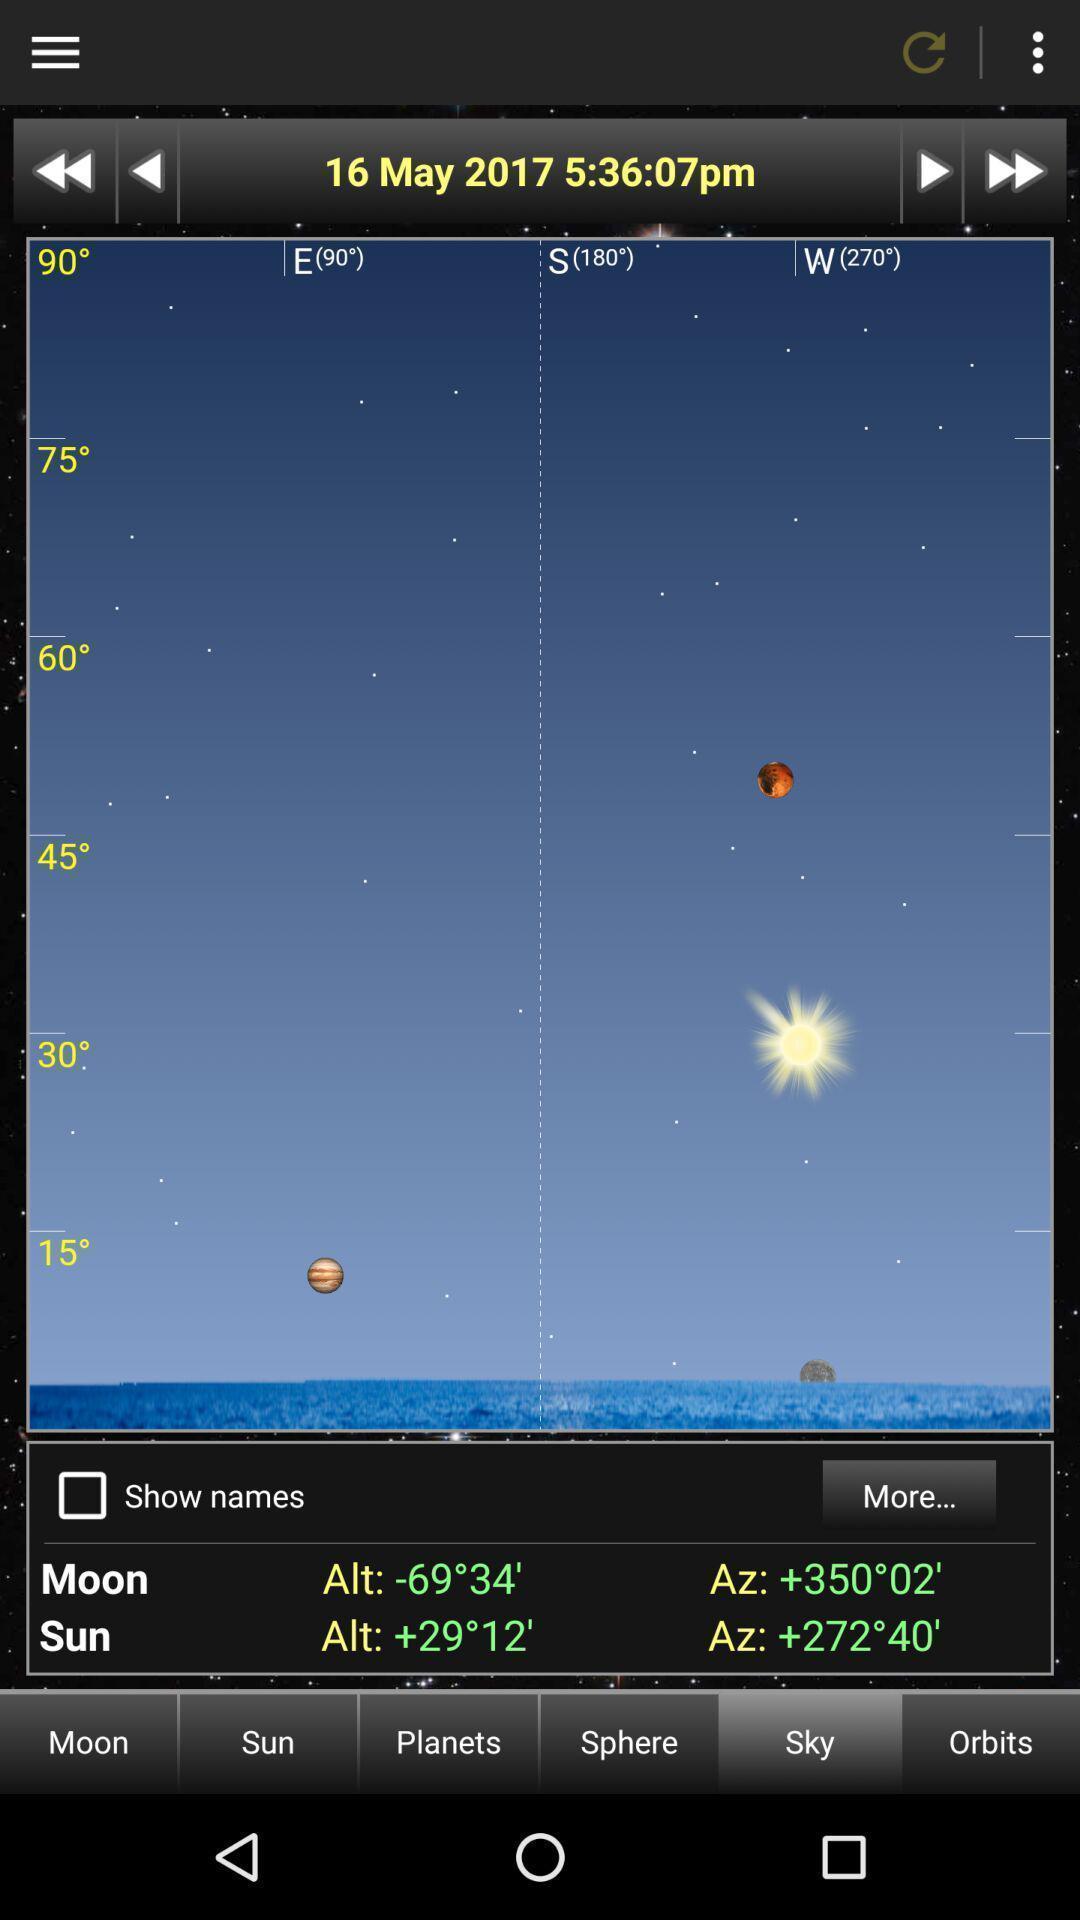Give me a summary of this screen capture. Screen displaying sky. 